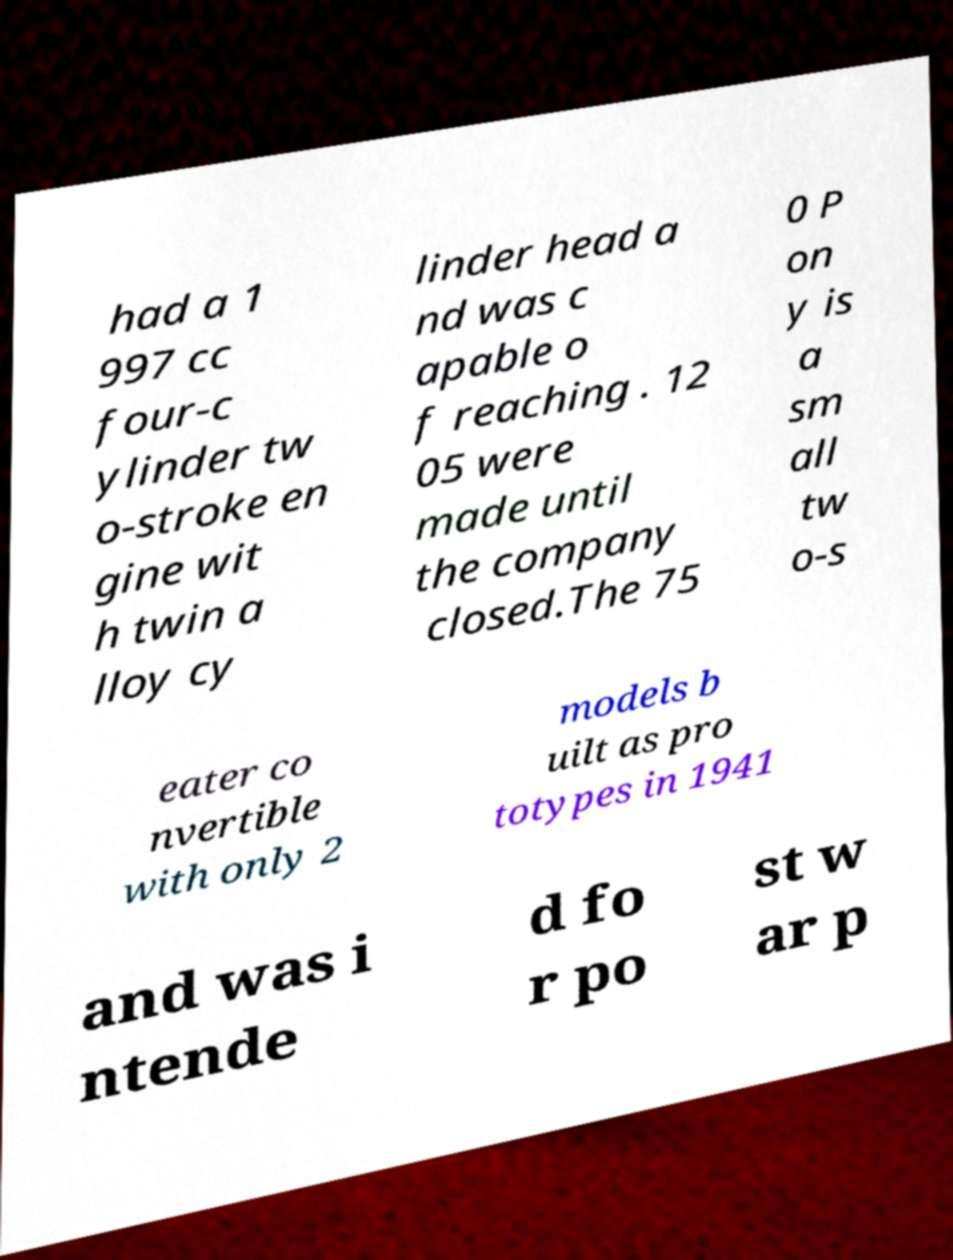Could you extract and type out the text from this image? had a 1 997 cc four-c ylinder tw o-stroke en gine wit h twin a lloy cy linder head a nd was c apable o f reaching . 12 05 were made until the company closed.The 75 0 P on y is a sm all tw o-s eater co nvertible with only 2 models b uilt as pro totypes in 1941 and was i ntende d fo r po st w ar p 